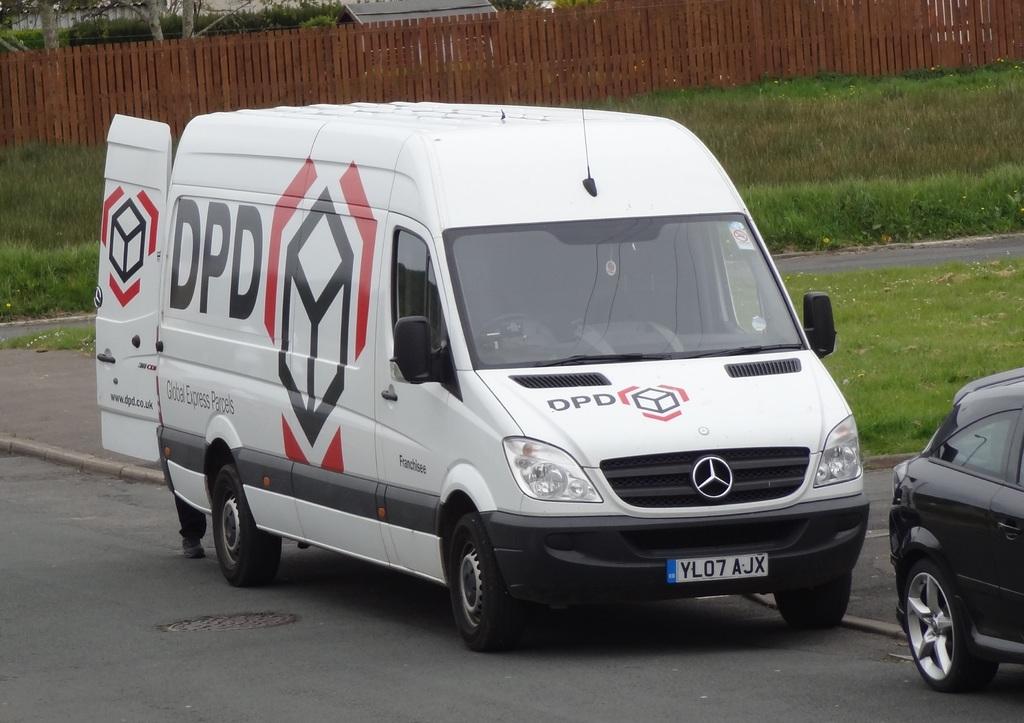Whos van is this?
Ensure brevity in your answer.  Dpd. What is the lisense plate?
Your response must be concise. Yl07 ajx. 